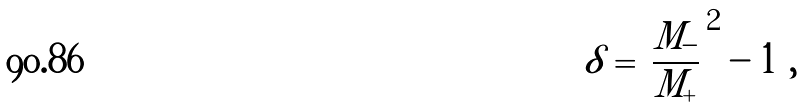<formula> <loc_0><loc_0><loc_500><loc_500>\delta = \left | \frac { M _ { - } } { M _ { + } } \right | ^ { 2 } - 1 \ ,</formula> 